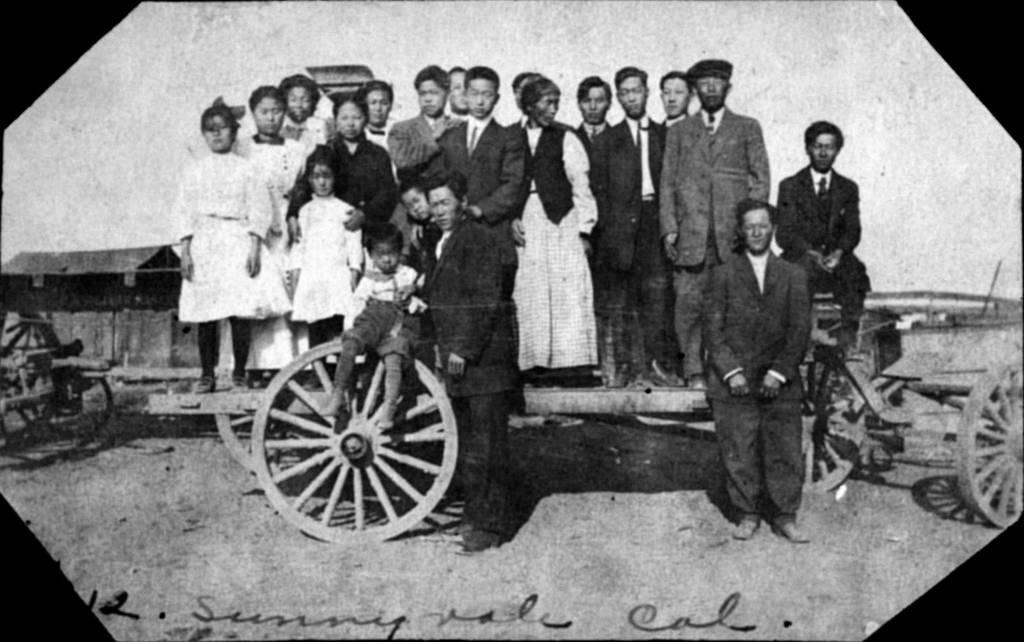What is the main subject in the center of the image? There is a group of persons standing in the center of the image. What is located in the center of the image with the group of persons? There is a wheel in the center of the image. What can be seen on the right side of the image? There are wheels on the right side of the image, and a cart is also present. What type of mitten is being worn by the person on the left side of the image? There is no person or mitten present on the left side of the image. What is the relation between the group of persons and the cart on the right side of the image? There is no information provided about the relation between the group of persons and the cart on the right side of the image. 